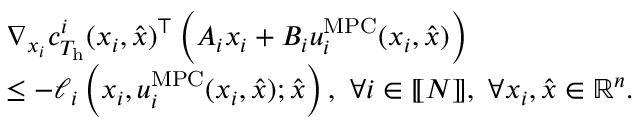Convert formula to latex. <formula><loc_0><loc_0><loc_500><loc_500>\begin{array} { r l } & { \nabla _ { x _ { i } } c _ { T _ { h } } ^ { i } ( x _ { i } , \hat { x } ) ^ { \top } \left ( A _ { i } x _ { i } + B _ { i } u _ { i } ^ { M P C } ( x _ { i } , \hat { x } ) \right ) } \\ & { \leq - \ell _ { i } \left ( x _ { i } , u _ { i } ^ { M P C } ( x _ { i } , \hat { x } ) ; \hat { x } \right ) , \ \forall i \in { [ \, [ N ] \, ] } , \ \forall x _ { i } , \hat { x } \in { \mathbb { R } } ^ { n } . } \end{array}</formula> 